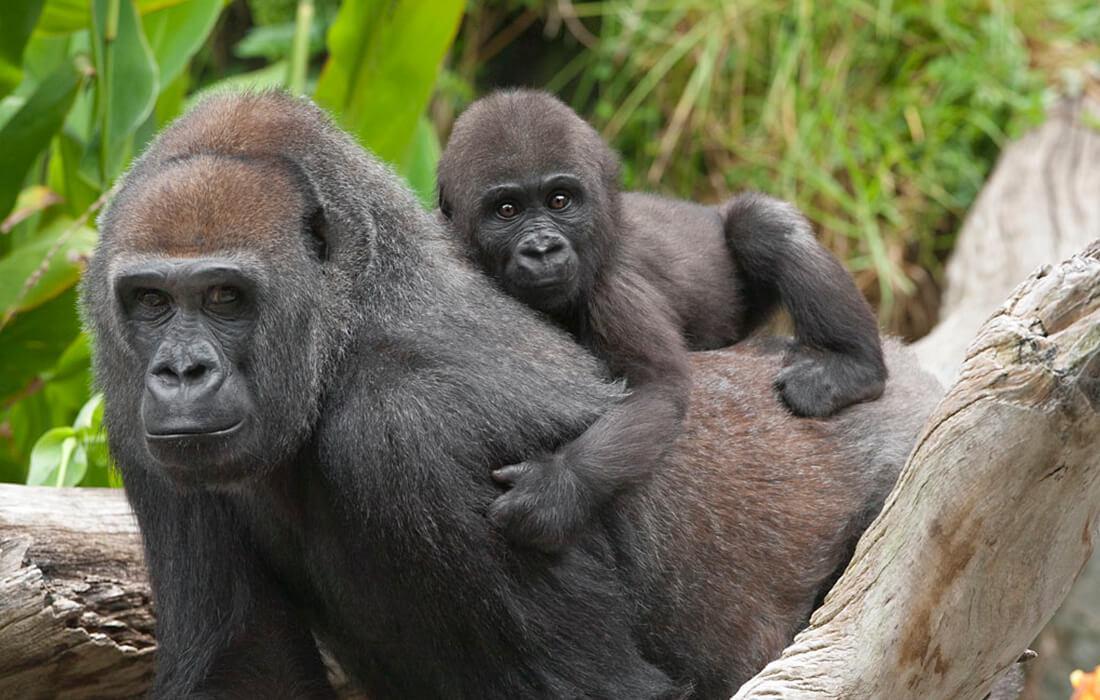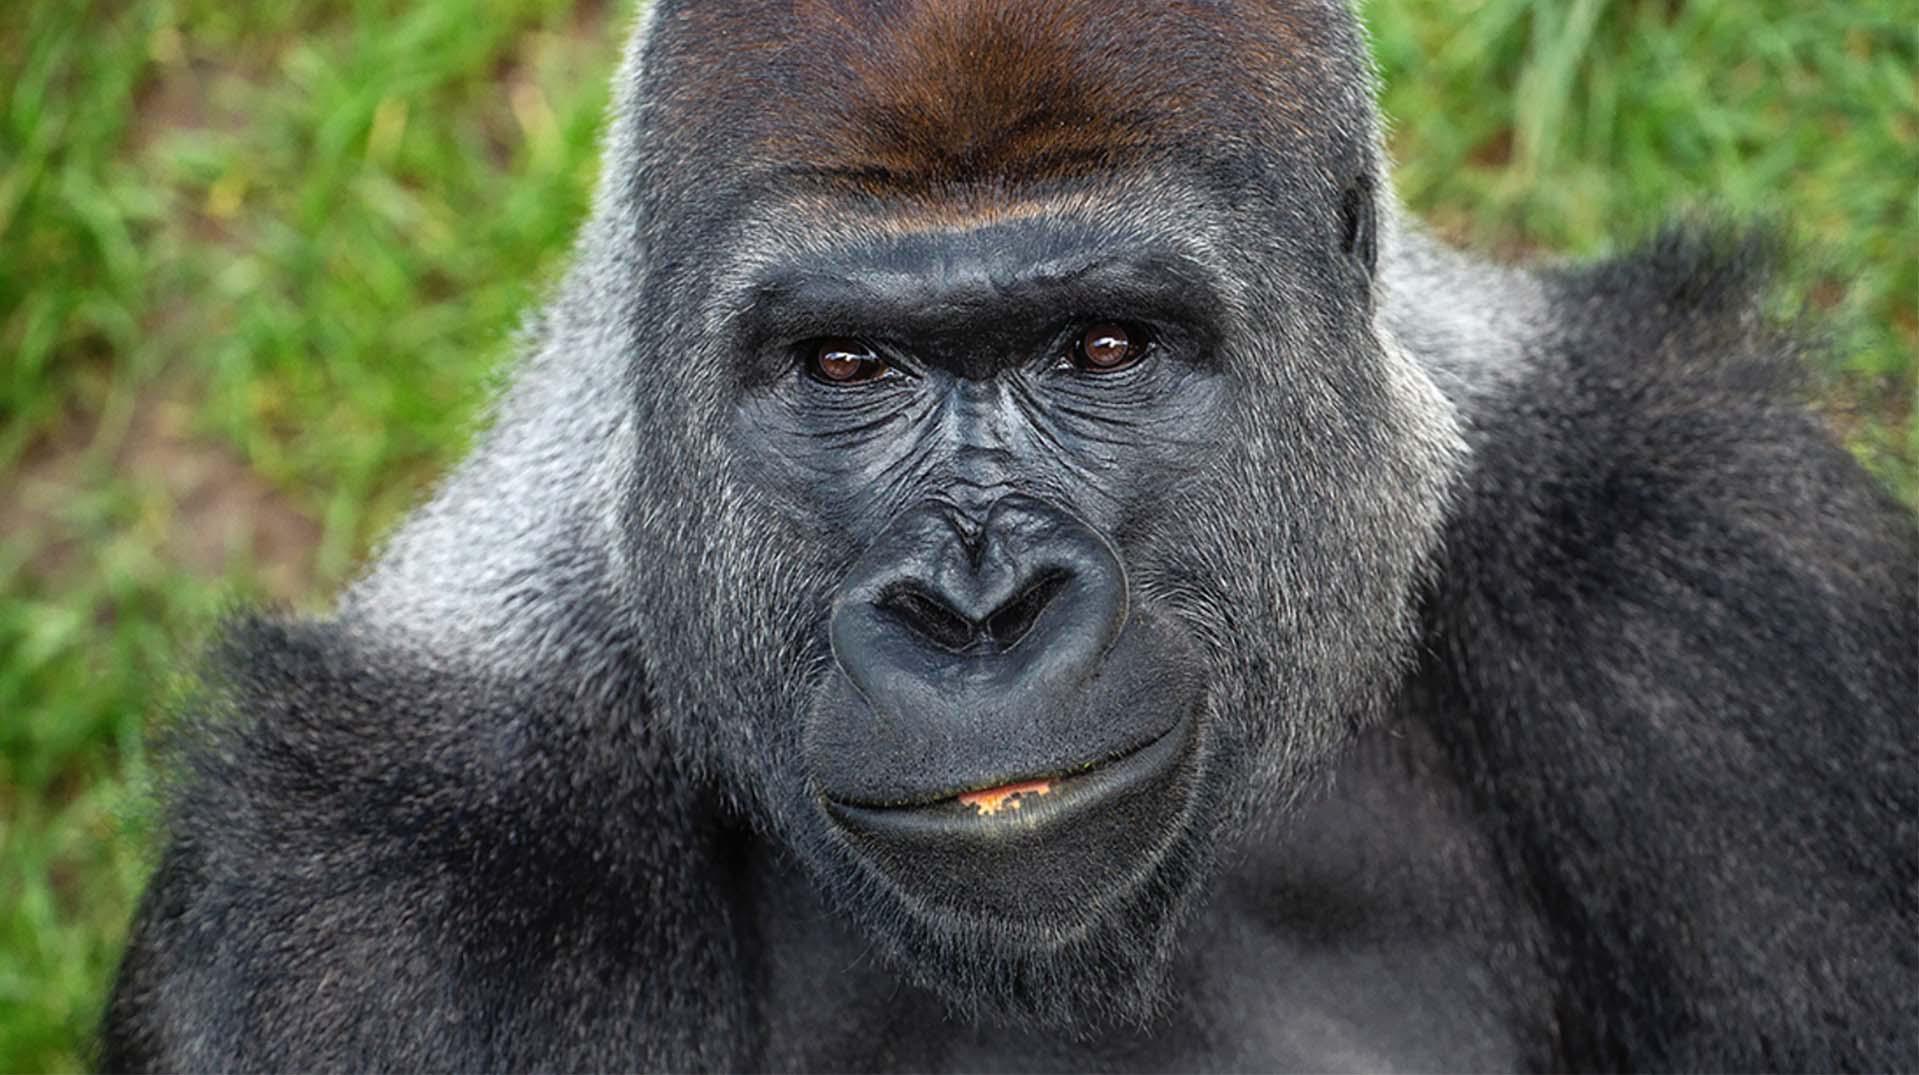The first image is the image on the left, the second image is the image on the right. For the images shown, is this caption "The image on the right shows exactly one adult gorilla." true? Answer yes or no. Yes. The first image is the image on the left, the second image is the image on the right. Examine the images to the left and right. Is the description "There are monkeys on rocks in one of the images" accurate? Answer yes or no. No. 